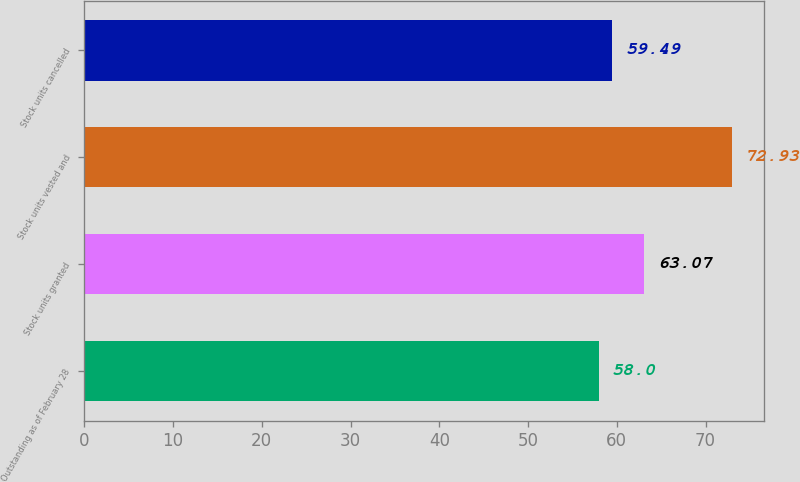Convert chart. <chart><loc_0><loc_0><loc_500><loc_500><bar_chart><fcel>Outstanding as of February 28<fcel>Stock units granted<fcel>Stock units vested and<fcel>Stock units cancelled<nl><fcel>58<fcel>63.07<fcel>72.93<fcel>59.49<nl></chart> 